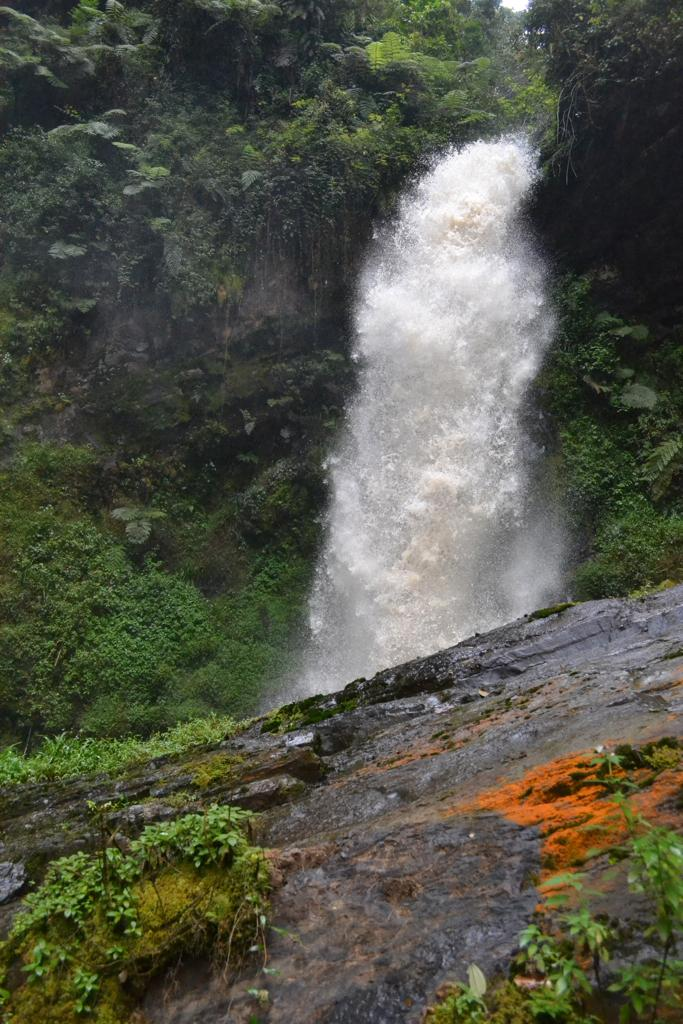What natural feature is the main subject of the image? There is a waterfall in the image. What is the primary element present in the image? Water is visible in the image. What type of vegetation can be seen in the image? There are trees and plants in the image. What geological feature is present in the image? There is a rock in the image. What type of fan can be seen in the image? There is no fan present in the image. Are there any bubbles visible in the water in the image? There is no mention of bubbles in the water in the image. 